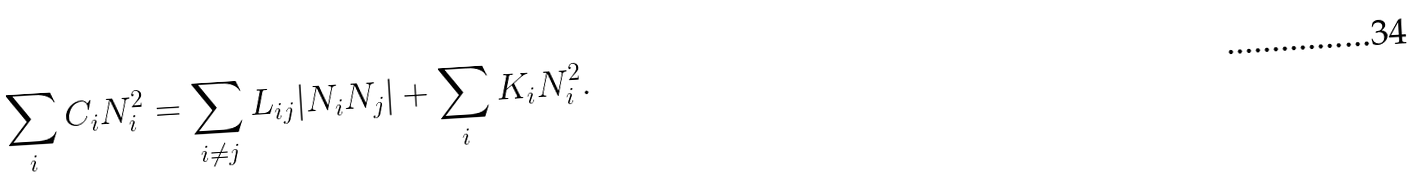Convert formula to latex. <formula><loc_0><loc_0><loc_500><loc_500>\sum _ { i } C _ { i } N _ { i } ^ { 2 } = \sum _ { i \neq j } L _ { i j } | N _ { i } N _ { j } | + \sum _ { i } K _ { i } N _ { i } ^ { 2 } .</formula> 